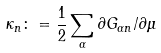<formula> <loc_0><loc_0><loc_500><loc_500>\kappa _ { n } \colon = \frac { 1 } { 2 } \sum _ { \alpha } \partial G _ { \alpha n } / \partial \mu</formula> 